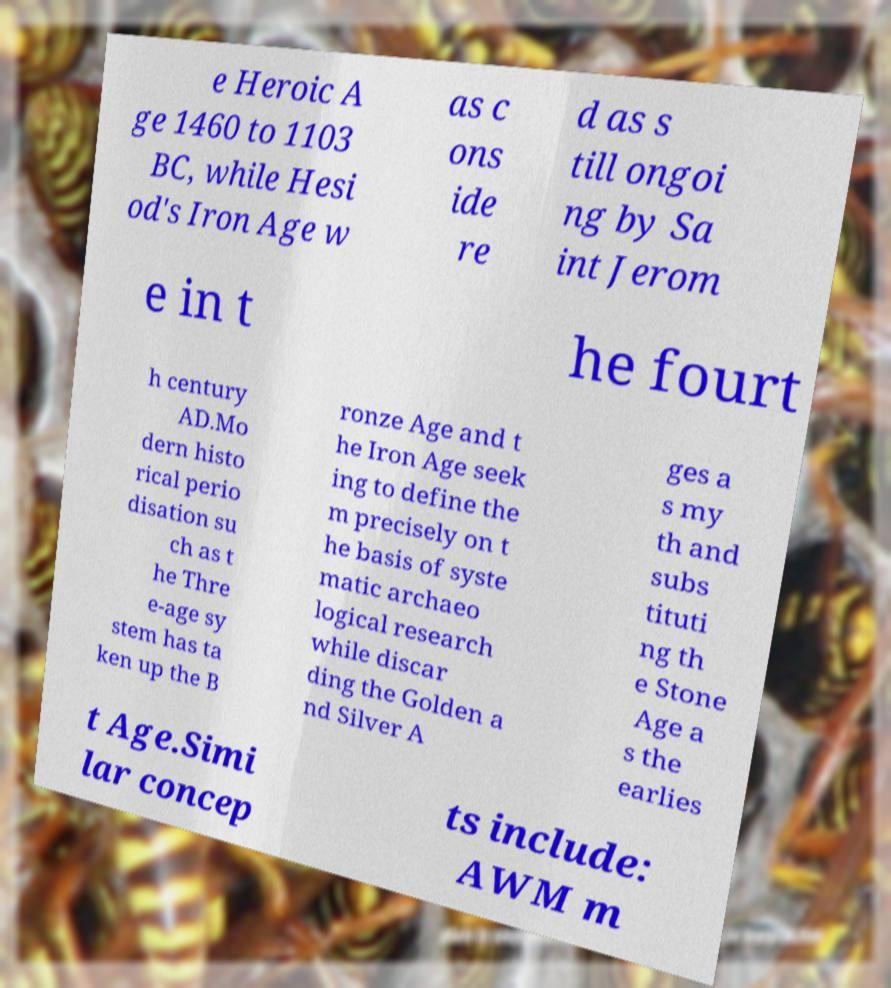Could you extract and type out the text from this image? e Heroic A ge 1460 to 1103 BC, while Hesi od's Iron Age w as c ons ide re d as s till ongoi ng by Sa int Jerom e in t he fourt h century AD.Mo dern histo rical perio disation su ch as t he Thre e-age sy stem has ta ken up the B ronze Age and t he Iron Age seek ing to define the m precisely on t he basis of syste matic archaeo logical research while discar ding the Golden a nd Silver A ges a s my th and subs tituti ng th e Stone Age a s the earlies t Age.Simi lar concep ts include: AWM m 